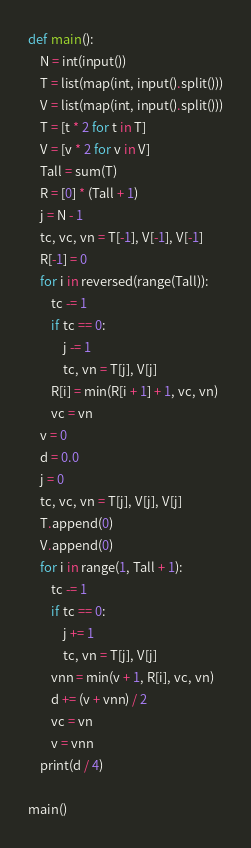Convert code to text. <code><loc_0><loc_0><loc_500><loc_500><_Python_>def main():
    N = int(input())
    T = list(map(int, input().split()))
    V = list(map(int, input().split()))
    T = [t * 2 for t in T]
    V = [v * 2 for v in V]
    Tall = sum(T)
    R = [0] * (Tall + 1)
    j = N - 1
    tc, vc, vn = T[-1], V[-1], V[-1]
    R[-1] = 0
    for i in reversed(range(Tall)):
        tc -= 1
        if tc == 0:
            j -= 1
            tc, vn = T[j], V[j]
        R[i] = min(R[i + 1] + 1, vc, vn)
        vc = vn
    v = 0
    d = 0.0
    j = 0
    tc, vc, vn = T[j], V[j], V[j]
    T.append(0)
    V.append(0)
    for i in range(1, Tall + 1):
        tc -= 1
        if tc == 0:
            j += 1
            tc, vn = T[j], V[j]
        vnn = min(v + 1, R[i], vc, vn)
        d += (v + vnn) / 2
        vc = vn
        v = vnn
    print(d / 4)

main()
</code> 